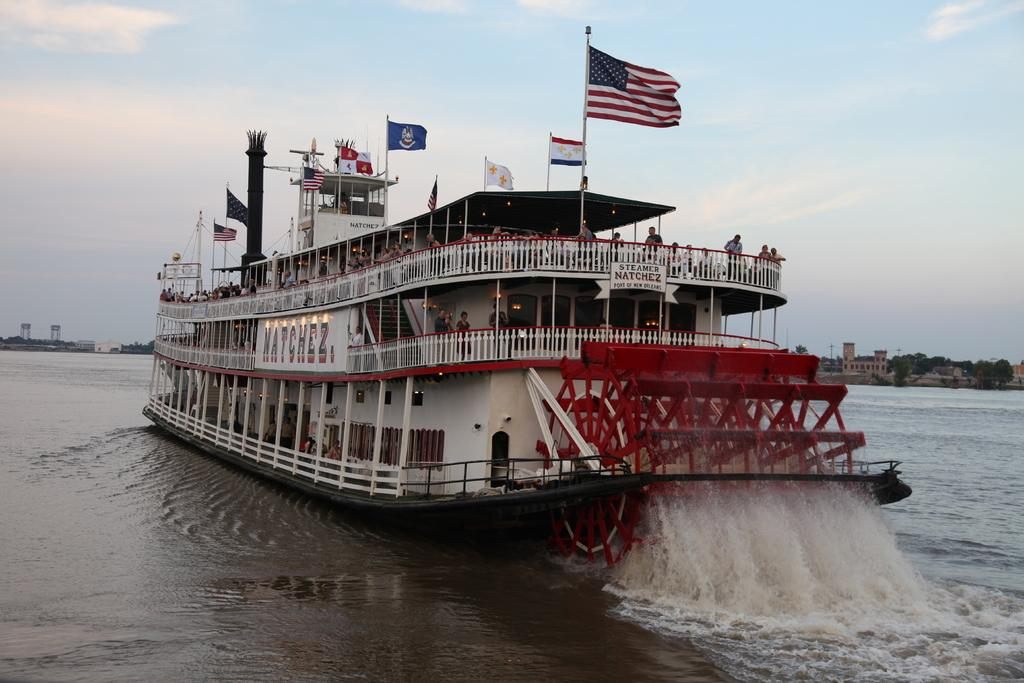What is: What is the main subject of the image? The main subject of the image is a ship. What can be seen on the right side of the image? The sea is visible on the right side of the image. What decorative elements are present on the ship? Flags are present on the ship. Are there any people visible in the image? Yes, people are standing on the ship. How would you describe the sky in the image? The sky is blue with some clouds. What type of gun is being used by the people on the ship in the image? There is no gun present in the image; people are standing on the ship without any visible weapons. Can you describe the facial expressions of the people on the ship in the image? There is no information about the facial expressions of the people on the ship in the image, as their faces are not visible or described. 